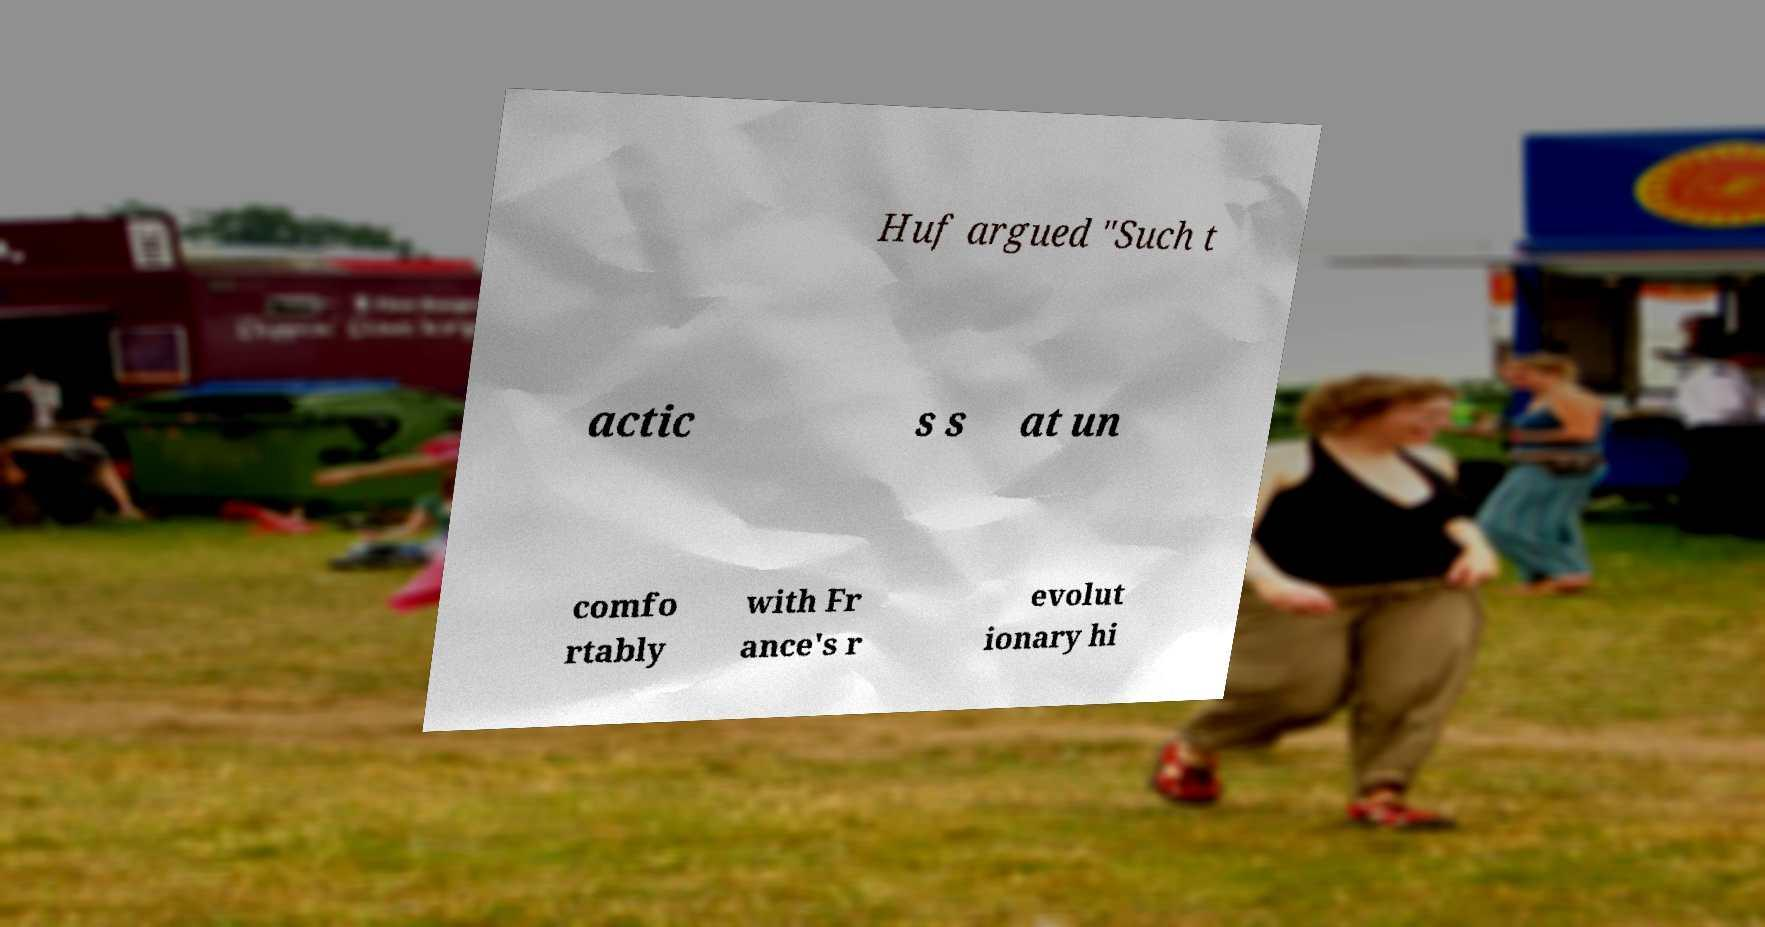Could you extract and type out the text from this image? Huf argued "Such t actic s s at un comfo rtably with Fr ance's r evolut ionary hi 